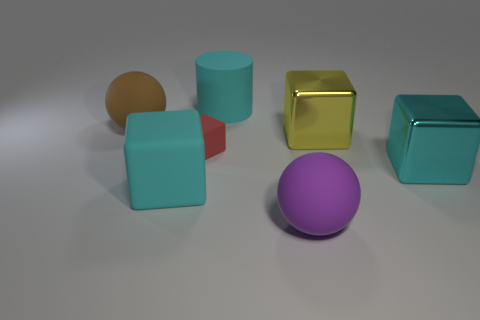Subtract all green cylinders. How many cyan cubes are left? 2 Subtract all large cyan metallic cubes. How many cubes are left? 3 Subtract all red cubes. How many cubes are left? 3 Subtract 1 blocks. How many blocks are left? 3 Add 2 purple matte balls. How many objects exist? 9 Subtract all blocks. How many objects are left? 3 Subtract all green blocks. Subtract all green balls. How many blocks are left? 4 Subtract all big brown objects. Subtract all tiny rubber cubes. How many objects are left? 5 Add 1 red blocks. How many red blocks are left? 2 Add 2 yellow cylinders. How many yellow cylinders exist? 2 